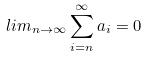Convert formula to latex. <formula><loc_0><loc_0><loc_500><loc_500>l i m _ { n \rightarrow \infty } \sum _ { i = n } ^ { \infty } a _ { i } = 0</formula> 